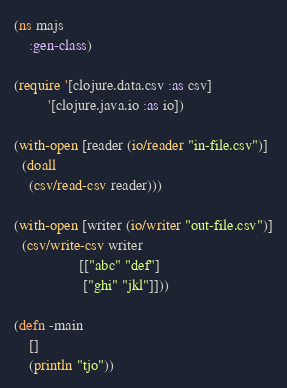Convert code to text. <code><loc_0><loc_0><loc_500><loc_500><_Clojure_>(ns majs
    :gen-class)

(require '[clojure.data.csv :as csv]
         '[clojure.java.io :as io])

(with-open [reader (io/reader "in-file.csv")]
  (doall
    (csv/read-csv reader)))

(with-open [writer (io/writer "out-file.csv")]
  (csv/write-csv writer
                 [["abc" "def"]
                  ["ghi" "jkl"]]))

(defn -main
    []
    (println "tjo"))</code> 